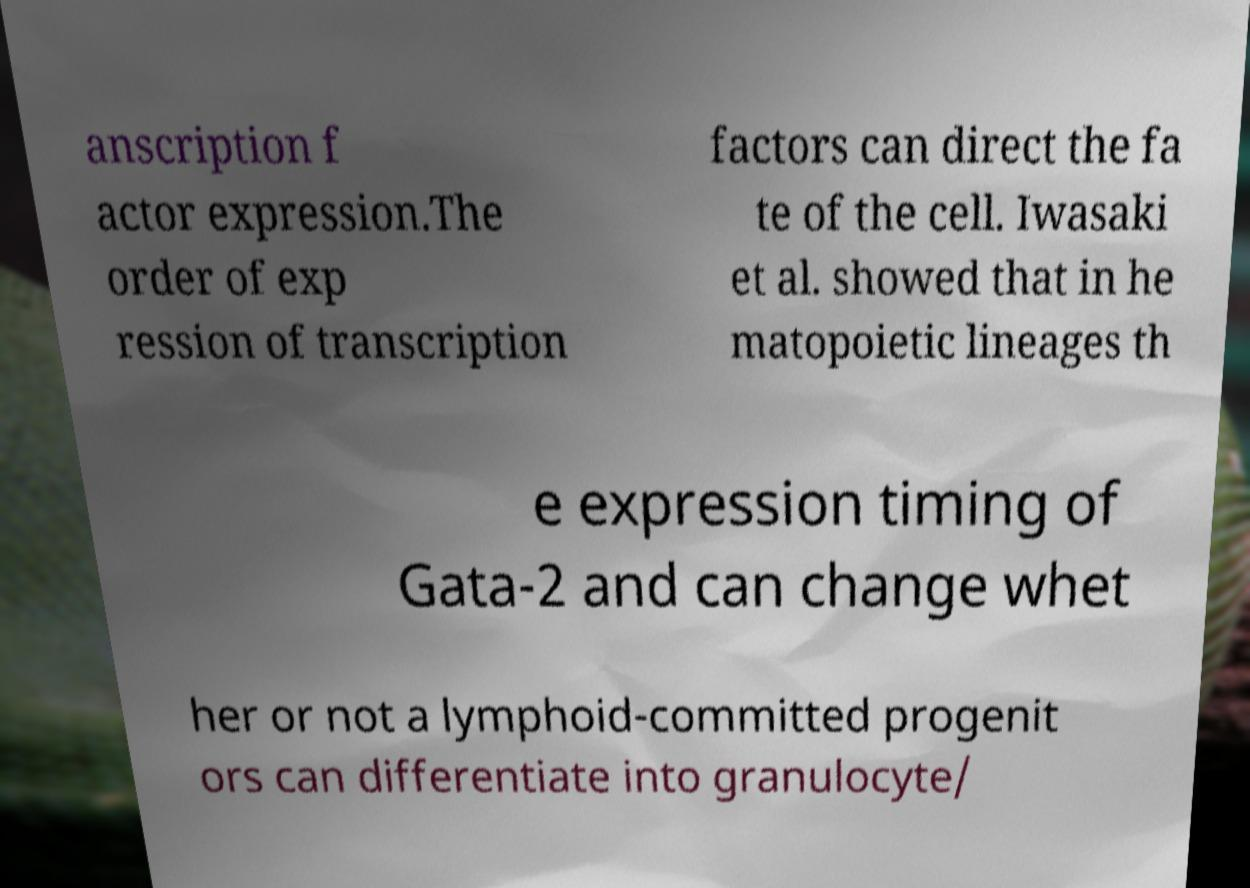Please read and relay the text visible in this image. What does it say? anscription f actor expression.The order of exp ression of transcription factors can direct the fa te of the cell. Iwasaki et al. showed that in he matopoietic lineages th e expression timing of Gata-2 and can change whet her or not a lymphoid-committed progenit ors can differentiate into granulocyte/ 